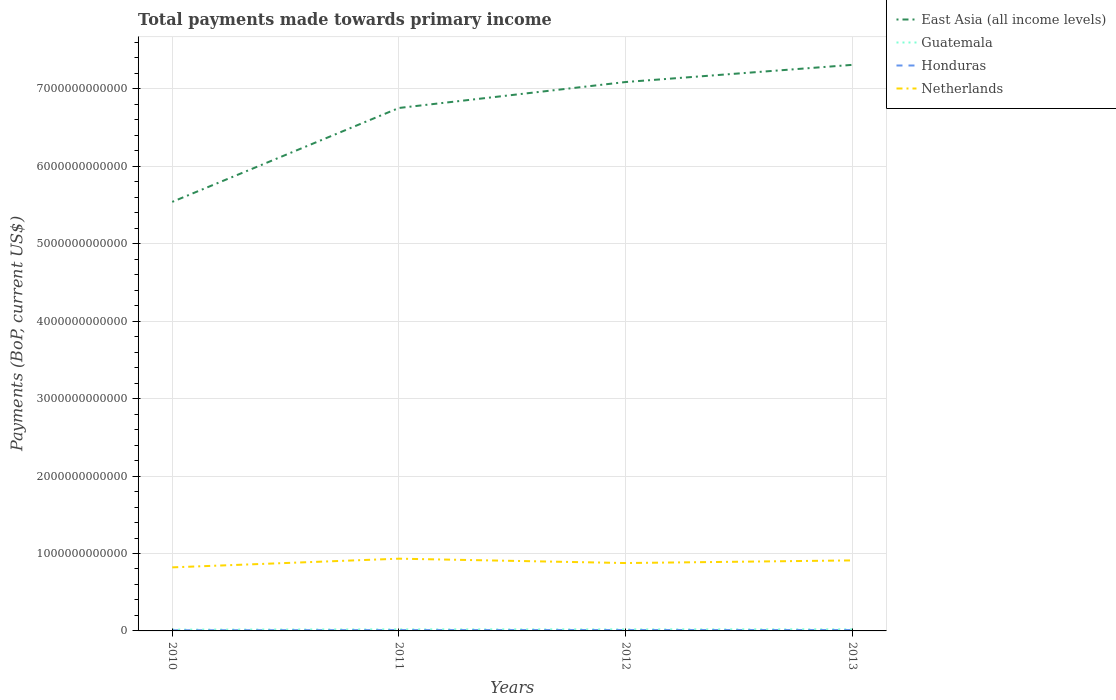Does the line corresponding to Netherlands intersect with the line corresponding to Guatemala?
Your answer should be very brief. No. Is the number of lines equal to the number of legend labels?
Provide a short and direct response. Yes. Across all years, what is the maximum total payments made towards primary income in Guatemala?
Provide a short and direct response. 1.67e+1. What is the total total payments made towards primary income in Guatemala in the graph?
Offer a terse response. -7.03e+08. What is the difference between the highest and the second highest total payments made towards primary income in Guatemala?
Give a very brief answer. 3.97e+09. How many lines are there?
Your response must be concise. 4. What is the difference between two consecutive major ticks on the Y-axis?
Offer a very short reply. 1.00e+12. Are the values on the major ticks of Y-axis written in scientific E-notation?
Provide a succinct answer. No. Does the graph contain any zero values?
Keep it short and to the point. No. Does the graph contain grids?
Provide a short and direct response. Yes. Where does the legend appear in the graph?
Your answer should be very brief. Top right. How are the legend labels stacked?
Your response must be concise. Vertical. What is the title of the graph?
Offer a terse response. Total payments made towards primary income. Does "Arab World" appear as one of the legend labels in the graph?
Offer a terse response. No. What is the label or title of the X-axis?
Your answer should be compact. Years. What is the label or title of the Y-axis?
Ensure brevity in your answer.  Payments (BoP, current US$). What is the Payments (BoP, current US$) of East Asia (all income levels) in 2010?
Your answer should be very brief. 5.54e+12. What is the Payments (BoP, current US$) of Guatemala in 2010?
Keep it short and to the point. 1.67e+1. What is the Payments (BoP, current US$) of Honduras in 2010?
Your response must be concise. 8.56e+09. What is the Payments (BoP, current US$) in Netherlands in 2010?
Provide a succinct answer. 8.21e+11. What is the Payments (BoP, current US$) of East Asia (all income levels) in 2011?
Your answer should be compact. 6.75e+12. What is the Payments (BoP, current US$) in Guatemala in 2011?
Your answer should be very brief. 1.99e+1. What is the Payments (BoP, current US$) in Honduras in 2011?
Your answer should be compact. 1.08e+1. What is the Payments (BoP, current US$) in Netherlands in 2011?
Offer a terse response. 9.33e+11. What is the Payments (BoP, current US$) in East Asia (all income levels) in 2012?
Make the answer very short. 7.09e+12. What is the Payments (BoP, current US$) in Guatemala in 2012?
Offer a very short reply. 1.99e+1. What is the Payments (BoP, current US$) of Honduras in 2012?
Your answer should be compact. 1.16e+1. What is the Payments (BoP, current US$) in Netherlands in 2012?
Ensure brevity in your answer.  8.77e+11. What is the Payments (BoP, current US$) of East Asia (all income levels) in 2013?
Offer a very short reply. 7.31e+12. What is the Payments (BoP, current US$) in Guatemala in 2013?
Provide a short and direct response. 2.06e+1. What is the Payments (BoP, current US$) in Honduras in 2013?
Your response must be concise. 1.14e+1. What is the Payments (BoP, current US$) in Netherlands in 2013?
Offer a very short reply. 9.11e+11. Across all years, what is the maximum Payments (BoP, current US$) in East Asia (all income levels)?
Offer a terse response. 7.31e+12. Across all years, what is the maximum Payments (BoP, current US$) in Guatemala?
Your response must be concise. 2.06e+1. Across all years, what is the maximum Payments (BoP, current US$) of Honduras?
Make the answer very short. 1.16e+1. Across all years, what is the maximum Payments (BoP, current US$) in Netherlands?
Provide a succinct answer. 9.33e+11. Across all years, what is the minimum Payments (BoP, current US$) of East Asia (all income levels)?
Offer a terse response. 5.54e+12. Across all years, what is the minimum Payments (BoP, current US$) in Guatemala?
Keep it short and to the point. 1.67e+1. Across all years, what is the minimum Payments (BoP, current US$) of Honduras?
Offer a very short reply. 8.56e+09. Across all years, what is the minimum Payments (BoP, current US$) in Netherlands?
Your answer should be compact. 8.21e+11. What is the total Payments (BoP, current US$) of East Asia (all income levels) in the graph?
Your answer should be compact. 2.67e+13. What is the total Payments (BoP, current US$) in Guatemala in the graph?
Give a very brief answer. 7.72e+1. What is the total Payments (BoP, current US$) in Honduras in the graph?
Your response must be concise. 4.24e+1. What is the total Payments (BoP, current US$) of Netherlands in the graph?
Make the answer very short. 3.54e+12. What is the difference between the Payments (BoP, current US$) of East Asia (all income levels) in 2010 and that in 2011?
Your response must be concise. -1.21e+12. What is the difference between the Payments (BoP, current US$) in Guatemala in 2010 and that in 2011?
Your answer should be compact. -3.23e+09. What is the difference between the Payments (BoP, current US$) of Honduras in 2010 and that in 2011?
Provide a succinct answer. -2.28e+09. What is the difference between the Payments (BoP, current US$) of Netherlands in 2010 and that in 2011?
Keep it short and to the point. -1.12e+11. What is the difference between the Payments (BoP, current US$) of East Asia (all income levels) in 2010 and that in 2012?
Your answer should be compact. -1.55e+12. What is the difference between the Payments (BoP, current US$) of Guatemala in 2010 and that in 2012?
Provide a succinct answer. -3.27e+09. What is the difference between the Payments (BoP, current US$) of Honduras in 2010 and that in 2012?
Offer a very short reply. -3.01e+09. What is the difference between the Payments (BoP, current US$) in Netherlands in 2010 and that in 2012?
Ensure brevity in your answer.  -5.58e+1. What is the difference between the Payments (BoP, current US$) of East Asia (all income levels) in 2010 and that in 2013?
Provide a succinct answer. -1.77e+12. What is the difference between the Payments (BoP, current US$) of Guatemala in 2010 and that in 2013?
Give a very brief answer. -3.97e+09. What is the difference between the Payments (BoP, current US$) of Honduras in 2010 and that in 2013?
Offer a very short reply. -2.87e+09. What is the difference between the Payments (BoP, current US$) in Netherlands in 2010 and that in 2013?
Provide a succinct answer. -8.98e+1. What is the difference between the Payments (BoP, current US$) in East Asia (all income levels) in 2011 and that in 2012?
Provide a succinct answer. -3.35e+11. What is the difference between the Payments (BoP, current US$) in Guatemala in 2011 and that in 2012?
Your answer should be very brief. -3.58e+07. What is the difference between the Payments (BoP, current US$) of Honduras in 2011 and that in 2012?
Your response must be concise. -7.32e+08. What is the difference between the Payments (BoP, current US$) of Netherlands in 2011 and that in 2012?
Provide a short and direct response. 5.64e+1. What is the difference between the Payments (BoP, current US$) in East Asia (all income levels) in 2011 and that in 2013?
Your response must be concise. -5.57e+11. What is the difference between the Payments (BoP, current US$) of Guatemala in 2011 and that in 2013?
Provide a succinct answer. -7.38e+08. What is the difference between the Payments (BoP, current US$) of Honduras in 2011 and that in 2013?
Give a very brief answer. -5.95e+08. What is the difference between the Payments (BoP, current US$) of Netherlands in 2011 and that in 2013?
Offer a very short reply. 2.24e+1. What is the difference between the Payments (BoP, current US$) of East Asia (all income levels) in 2012 and that in 2013?
Ensure brevity in your answer.  -2.22e+11. What is the difference between the Payments (BoP, current US$) of Guatemala in 2012 and that in 2013?
Ensure brevity in your answer.  -7.03e+08. What is the difference between the Payments (BoP, current US$) of Honduras in 2012 and that in 2013?
Your answer should be very brief. 1.38e+08. What is the difference between the Payments (BoP, current US$) in Netherlands in 2012 and that in 2013?
Offer a very short reply. -3.40e+1. What is the difference between the Payments (BoP, current US$) in East Asia (all income levels) in 2010 and the Payments (BoP, current US$) in Guatemala in 2011?
Ensure brevity in your answer.  5.52e+12. What is the difference between the Payments (BoP, current US$) of East Asia (all income levels) in 2010 and the Payments (BoP, current US$) of Honduras in 2011?
Give a very brief answer. 5.53e+12. What is the difference between the Payments (BoP, current US$) of East Asia (all income levels) in 2010 and the Payments (BoP, current US$) of Netherlands in 2011?
Your response must be concise. 4.61e+12. What is the difference between the Payments (BoP, current US$) of Guatemala in 2010 and the Payments (BoP, current US$) of Honduras in 2011?
Ensure brevity in your answer.  5.84e+09. What is the difference between the Payments (BoP, current US$) of Guatemala in 2010 and the Payments (BoP, current US$) of Netherlands in 2011?
Give a very brief answer. -9.16e+11. What is the difference between the Payments (BoP, current US$) in Honduras in 2010 and the Payments (BoP, current US$) in Netherlands in 2011?
Keep it short and to the point. -9.24e+11. What is the difference between the Payments (BoP, current US$) of East Asia (all income levels) in 2010 and the Payments (BoP, current US$) of Guatemala in 2012?
Offer a terse response. 5.52e+12. What is the difference between the Payments (BoP, current US$) of East Asia (all income levels) in 2010 and the Payments (BoP, current US$) of Honduras in 2012?
Offer a terse response. 5.53e+12. What is the difference between the Payments (BoP, current US$) of East Asia (all income levels) in 2010 and the Payments (BoP, current US$) of Netherlands in 2012?
Offer a terse response. 4.66e+12. What is the difference between the Payments (BoP, current US$) of Guatemala in 2010 and the Payments (BoP, current US$) of Honduras in 2012?
Make the answer very short. 5.11e+09. What is the difference between the Payments (BoP, current US$) in Guatemala in 2010 and the Payments (BoP, current US$) in Netherlands in 2012?
Offer a very short reply. -8.60e+11. What is the difference between the Payments (BoP, current US$) of Honduras in 2010 and the Payments (BoP, current US$) of Netherlands in 2012?
Your answer should be very brief. -8.68e+11. What is the difference between the Payments (BoP, current US$) of East Asia (all income levels) in 2010 and the Payments (BoP, current US$) of Guatemala in 2013?
Offer a terse response. 5.52e+12. What is the difference between the Payments (BoP, current US$) in East Asia (all income levels) in 2010 and the Payments (BoP, current US$) in Honduras in 2013?
Your answer should be compact. 5.53e+12. What is the difference between the Payments (BoP, current US$) in East Asia (all income levels) in 2010 and the Payments (BoP, current US$) in Netherlands in 2013?
Provide a succinct answer. 4.63e+12. What is the difference between the Payments (BoP, current US$) in Guatemala in 2010 and the Payments (BoP, current US$) in Honduras in 2013?
Offer a terse response. 5.24e+09. What is the difference between the Payments (BoP, current US$) of Guatemala in 2010 and the Payments (BoP, current US$) of Netherlands in 2013?
Offer a very short reply. -8.94e+11. What is the difference between the Payments (BoP, current US$) of Honduras in 2010 and the Payments (BoP, current US$) of Netherlands in 2013?
Your response must be concise. -9.02e+11. What is the difference between the Payments (BoP, current US$) in East Asia (all income levels) in 2011 and the Payments (BoP, current US$) in Guatemala in 2012?
Keep it short and to the point. 6.73e+12. What is the difference between the Payments (BoP, current US$) of East Asia (all income levels) in 2011 and the Payments (BoP, current US$) of Honduras in 2012?
Your answer should be very brief. 6.74e+12. What is the difference between the Payments (BoP, current US$) in East Asia (all income levels) in 2011 and the Payments (BoP, current US$) in Netherlands in 2012?
Your answer should be compact. 5.88e+12. What is the difference between the Payments (BoP, current US$) in Guatemala in 2011 and the Payments (BoP, current US$) in Honduras in 2012?
Offer a very short reply. 8.34e+09. What is the difference between the Payments (BoP, current US$) in Guatemala in 2011 and the Payments (BoP, current US$) in Netherlands in 2012?
Ensure brevity in your answer.  -8.57e+11. What is the difference between the Payments (BoP, current US$) in Honduras in 2011 and the Payments (BoP, current US$) in Netherlands in 2012?
Offer a terse response. -8.66e+11. What is the difference between the Payments (BoP, current US$) of East Asia (all income levels) in 2011 and the Payments (BoP, current US$) of Guatemala in 2013?
Provide a succinct answer. 6.73e+12. What is the difference between the Payments (BoP, current US$) in East Asia (all income levels) in 2011 and the Payments (BoP, current US$) in Honduras in 2013?
Ensure brevity in your answer.  6.74e+12. What is the difference between the Payments (BoP, current US$) in East Asia (all income levels) in 2011 and the Payments (BoP, current US$) in Netherlands in 2013?
Give a very brief answer. 5.84e+12. What is the difference between the Payments (BoP, current US$) of Guatemala in 2011 and the Payments (BoP, current US$) of Honduras in 2013?
Make the answer very short. 8.47e+09. What is the difference between the Payments (BoP, current US$) in Guatemala in 2011 and the Payments (BoP, current US$) in Netherlands in 2013?
Offer a terse response. -8.91e+11. What is the difference between the Payments (BoP, current US$) of Honduras in 2011 and the Payments (BoP, current US$) of Netherlands in 2013?
Provide a succinct answer. -9.00e+11. What is the difference between the Payments (BoP, current US$) of East Asia (all income levels) in 2012 and the Payments (BoP, current US$) of Guatemala in 2013?
Provide a succinct answer. 7.07e+12. What is the difference between the Payments (BoP, current US$) of East Asia (all income levels) in 2012 and the Payments (BoP, current US$) of Honduras in 2013?
Your answer should be very brief. 7.08e+12. What is the difference between the Payments (BoP, current US$) of East Asia (all income levels) in 2012 and the Payments (BoP, current US$) of Netherlands in 2013?
Make the answer very short. 6.18e+12. What is the difference between the Payments (BoP, current US$) in Guatemala in 2012 and the Payments (BoP, current US$) in Honduras in 2013?
Offer a terse response. 8.51e+09. What is the difference between the Payments (BoP, current US$) of Guatemala in 2012 and the Payments (BoP, current US$) of Netherlands in 2013?
Make the answer very short. -8.91e+11. What is the difference between the Payments (BoP, current US$) in Honduras in 2012 and the Payments (BoP, current US$) in Netherlands in 2013?
Keep it short and to the point. -8.99e+11. What is the average Payments (BoP, current US$) in East Asia (all income levels) per year?
Your response must be concise. 6.67e+12. What is the average Payments (BoP, current US$) in Guatemala per year?
Ensure brevity in your answer.  1.93e+1. What is the average Payments (BoP, current US$) in Honduras per year?
Ensure brevity in your answer.  1.06e+1. What is the average Payments (BoP, current US$) in Netherlands per year?
Offer a very short reply. 8.85e+11. In the year 2010, what is the difference between the Payments (BoP, current US$) of East Asia (all income levels) and Payments (BoP, current US$) of Guatemala?
Your response must be concise. 5.52e+12. In the year 2010, what is the difference between the Payments (BoP, current US$) in East Asia (all income levels) and Payments (BoP, current US$) in Honduras?
Your response must be concise. 5.53e+12. In the year 2010, what is the difference between the Payments (BoP, current US$) in East Asia (all income levels) and Payments (BoP, current US$) in Netherlands?
Give a very brief answer. 4.72e+12. In the year 2010, what is the difference between the Payments (BoP, current US$) in Guatemala and Payments (BoP, current US$) in Honduras?
Offer a terse response. 8.12e+09. In the year 2010, what is the difference between the Payments (BoP, current US$) in Guatemala and Payments (BoP, current US$) in Netherlands?
Your answer should be very brief. -8.04e+11. In the year 2010, what is the difference between the Payments (BoP, current US$) of Honduras and Payments (BoP, current US$) of Netherlands?
Keep it short and to the point. -8.12e+11. In the year 2011, what is the difference between the Payments (BoP, current US$) of East Asia (all income levels) and Payments (BoP, current US$) of Guatemala?
Offer a terse response. 6.73e+12. In the year 2011, what is the difference between the Payments (BoP, current US$) in East Asia (all income levels) and Payments (BoP, current US$) in Honduras?
Give a very brief answer. 6.74e+12. In the year 2011, what is the difference between the Payments (BoP, current US$) in East Asia (all income levels) and Payments (BoP, current US$) in Netherlands?
Your response must be concise. 5.82e+12. In the year 2011, what is the difference between the Payments (BoP, current US$) in Guatemala and Payments (BoP, current US$) in Honduras?
Your answer should be very brief. 9.07e+09. In the year 2011, what is the difference between the Payments (BoP, current US$) of Guatemala and Payments (BoP, current US$) of Netherlands?
Ensure brevity in your answer.  -9.13e+11. In the year 2011, what is the difference between the Payments (BoP, current US$) of Honduras and Payments (BoP, current US$) of Netherlands?
Give a very brief answer. -9.22e+11. In the year 2012, what is the difference between the Payments (BoP, current US$) in East Asia (all income levels) and Payments (BoP, current US$) in Guatemala?
Keep it short and to the point. 7.07e+12. In the year 2012, what is the difference between the Payments (BoP, current US$) in East Asia (all income levels) and Payments (BoP, current US$) in Honduras?
Make the answer very short. 7.08e+12. In the year 2012, what is the difference between the Payments (BoP, current US$) in East Asia (all income levels) and Payments (BoP, current US$) in Netherlands?
Offer a terse response. 6.21e+12. In the year 2012, what is the difference between the Payments (BoP, current US$) in Guatemala and Payments (BoP, current US$) in Honduras?
Ensure brevity in your answer.  8.37e+09. In the year 2012, what is the difference between the Payments (BoP, current US$) of Guatemala and Payments (BoP, current US$) of Netherlands?
Your answer should be compact. -8.57e+11. In the year 2012, what is the difference between the Payments (BoP, current US$) in Honduras and Payments (BoP, current US$) in Netherlands?
Offer a terse response. -8.65e+11. In the year 2013, what is the difference between the Payments (BoP, current US$) in East Asia (all income levels) and Payments (BoP, current US$) in Guatemala?
Make the answer very short. 7.29e+12. In the year 2013, what is the difference between the Payments (BoP, current US$) in East Asia (all income levels) and Payments (BoP, current US$) in Honduras?
Give a very brief answer. 7.30e+12. In the year 2013, what is the difference between the Payments (BoP, current US$) in East Asia (all income levels) and Payments (BoP, current US$) in Netherlands?
Give a very brief answer. 6.40e+12. In the year 2013, what is the difference between the Payments (BoP, current US$) of Guatemala and Payments (BoP, current US$) of Honduras?
Your answer should be very brief. 9.21e+09. In the year 2013, what is the difference between the Payments (BoP, current US$) in Guatemala and Payments (BoP, current US$) in Netherlands?
Your answer should be compact. -8.90e+11. In the year 2013, what is the difference between the Payments (BoP, current US$) in Honduras and Payments (BoP, current US$) in Netherlands?
Make the answer very short. -8.99e+11. What is the ratio of the Payments (BoP, current US$) in East Asia (all income levels) in 2010 to that in 2011?
Keep it short and to the point. 0.82. What is the ratio of the Payments (BoP, current US$) of Guatemala in 2010 to that in 2011?
Your answer should be very brief. 0.84. What is the ratio of the Payments (BoP, current US$) in Honduras in 2010 to that in 2011?
Your response must be concise. 0.79. What is the ratio of the Payments (BoP, current US$) of Netherlands in 2010 to that in 2011?
Your answer should be compact. 0.88. What is the ratio of the Payments (BoP, current US$) of East Asia (all income levels) in 2010 to that in 2012?
Offer a very short reply. 0.78. What is the ratio of the Payments (BoP, current US$) of Guatemala in 2010 to that in 2012?
Make the answer very short. 0.84. What is the ratio of the Payments (BoP, current US$) in Honduras in 2010 to that in 2012?
Make the answer very short. 0.74. What is the ratio of the Payments (BoP, current US$) in Netherlands in 2010 to that in 2012?
Your answer should be very brief. 0.94. What is the ratio of the Payments (BoP, current US$) of East Asia (all income levels) in 2010 to that in 2013?
Your response must be concise. 0.76. What is the ratio of the Payments (BoP, current US$) in Guatemala in 2010 to that in 2013?
Provide a succinct answer. 0.81. What is the ratio of the Payments (BoP, current US$) of Honduras in 2010 to that in 2013?
Give a very brief answer. 0.75. What is the ratio of the Payments (BoP, current US$) in Netherlands in 2010 to that in 2013?
Provide a short and direct response. 0.9. What is the ratio of the Payments (BoP, current US$) of East Asia (all income levels) in 2011 to that in 2012?
Ensure brevity in your answer.  0.95. What is the ratio of the Payments (BoP, current US$) in Honduras in 2011 to that in 2012?
Provide a succinct answer. 0.94. What is the ratio of the Payments (BoP, current US$) in Netherlands in 2011 to that in 2012?
Offer a terse response. 1.06. What is the ratio of the Payments (BoP, current US$) of East Asia (all income levels) in 2011 to that in 2013?
Your answer should be compact. 0.92. What is the ratio of the Payments (BoP, current US$) of Guatemala in 2011 to that in 2013?
Ensure brevity in your answer.  0.96. What is the ratio of the Payments (BoP, current US$) of Honduras in 2011 to that in 2013?
Ensure brevity in your answer.  0.95. What is the ratio of the Payments (BoP, current US$) of Netherlands in 2011 to that in 2013?
Keep it short and to the point. 1.02. What is the ratio of the Payments (BoP, current US$) in East Asia (all income levels) in 2012 to that in 2013?
Your response must be concise. 0.97. What is the ratio of the Payments (BoP, current US$) in Guatemala in 2012 to that in 2013?
Your response must be concise. 0.97. What is the ratio of the Payments (BoP, current US$) of Honduras in 2012 to that in 2013?
Your answer should be very brief. 1.01. What is the ratio of the Payments (BoP, current US$) of Netherlands in 2012 to that in 2013?
Provide a succinct answer. 0.96. What is the difference between the highest and the second highest Payments (BoP, current US$) in East Asia (all income levels)?
Your answer should be very brief. 2.22e+11. What is the difference between the highest and the second highest Payments (BoP, current US$) in Guatemala?
Your answer should be very brief. 7.03e+08. What is the difference between the highest and the second highest Payments (BoP, current US$) in Honduras?
Provide a short and direct response. 1.38e+08. What is the difference between the highest and the second highest Payments (BoP, current US$) in Netherlands?
Provide a short and direct response. 2.24e+1. What is the difference between the highest and the lowest Payments (BoP, current US$) in East Asia (all income levels)?
Your response must be concise. 1.77e+12. What is the difference between the highest and the lowest Payments (BoP, current US$) of Guatemala?
Give a very brief answer. 3.97e+09. What is the difference between the highest and the lowest Payments (BoP, current US$) in Honduras?
Provide a succinct answer. 3.01e+09. What is the difference between the highest and the lowest Payments (BoP, current US$) of Netherlands?
Ensure brevity in your answer.  1.12e+11. 